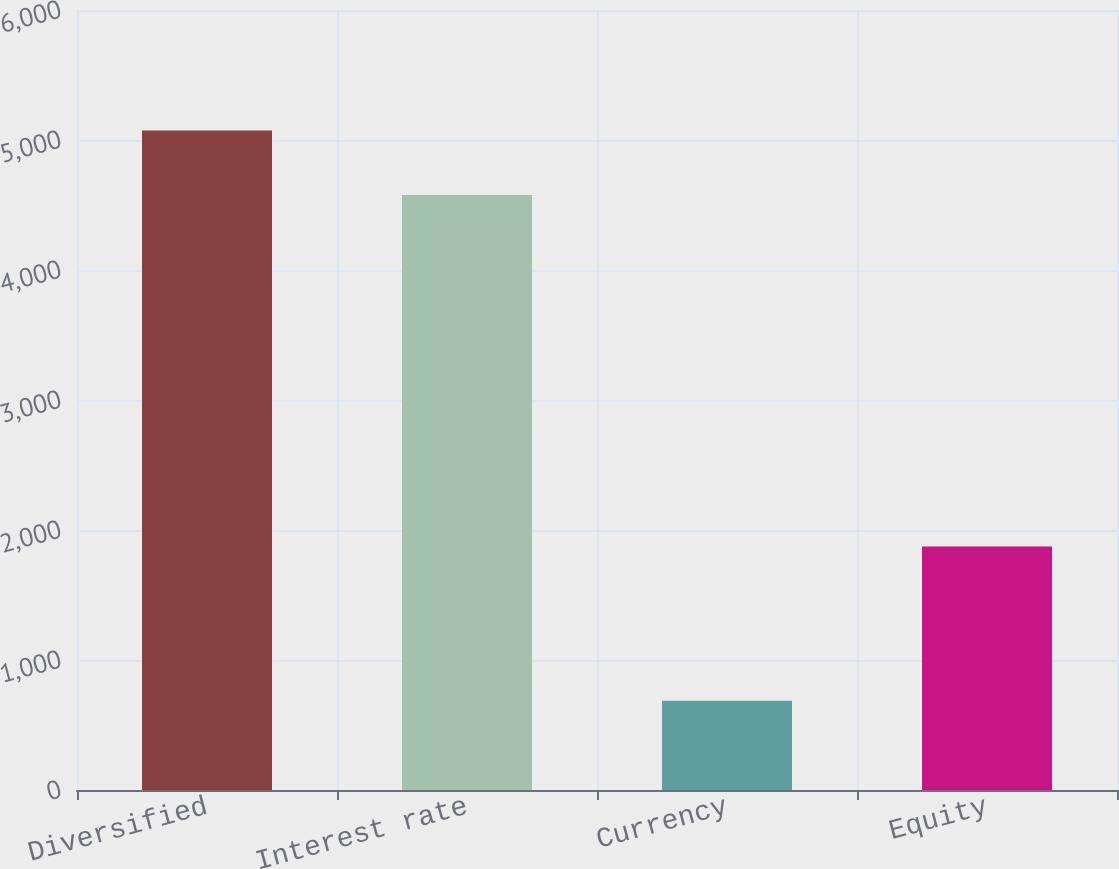Convert chart to OTSL. <chart><loc_0><loc_0><loc_500><loc_500><bar_chart><fcel>Diversified<fcel>Interest rate<fcel>Currency<fcel>Equity<nl><fcel>5073<fcel>4577<fcel>686<fcel>1873<nl></chart> 